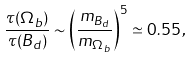Convert formula to latex. <formula><loc_0><loc_0><loc_500><loc_500>\frac { \tau ( { \sl \Omega } _ { b } ) } { \tau ( B _ { d } ) } \sim \left ( \frac { m _ { B _ { d } } } { m _ { { \sl \Omega } _ { b } } } \right ) ^ { 5 } \simeq 0 . 5 5 \, ,</formula> 